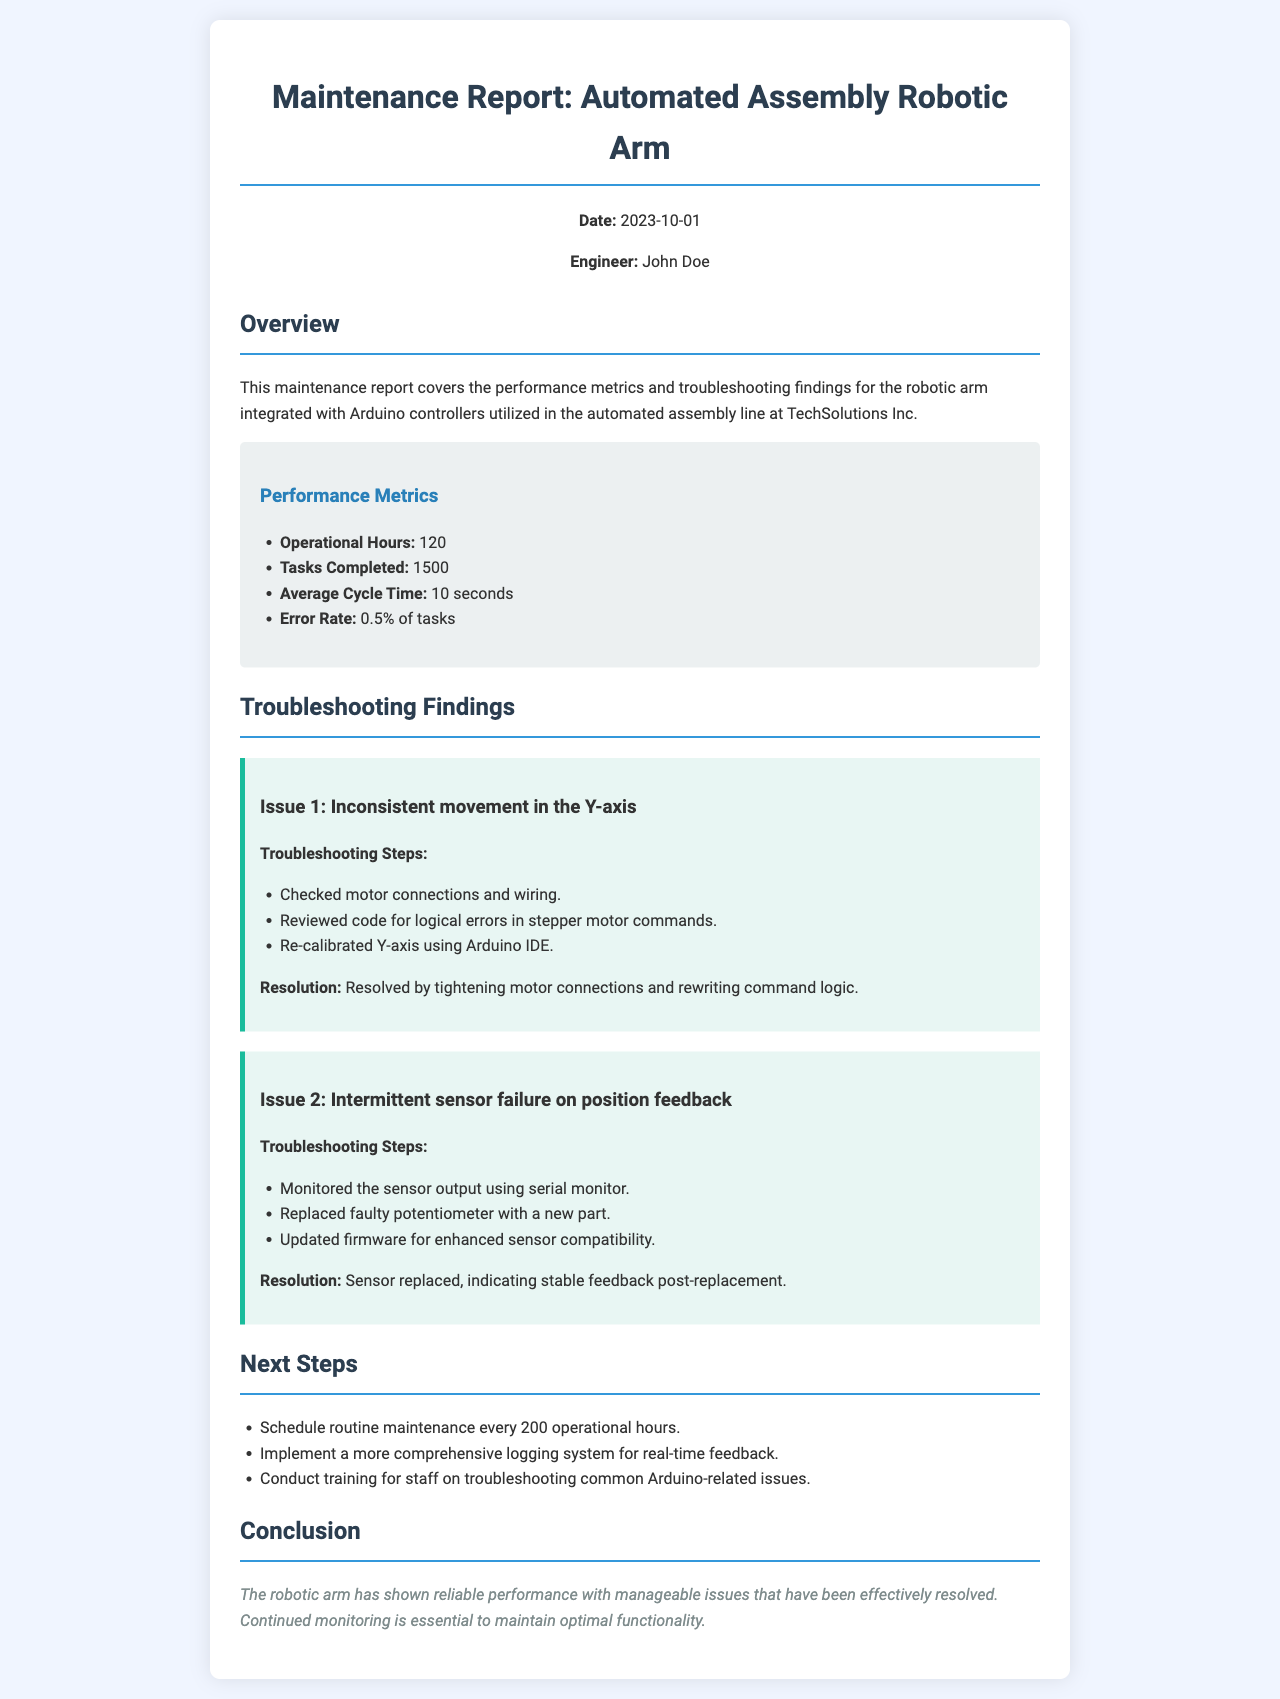What is the date of the report? The date of the report is explicitly mentioned in the document.
Answer: 2023-10-01 Who is the engineer responsible for the report? The engineer's name is provided in the document as the person responsible for the report.
Answer: John Doe How many operational hours has the robotic arm completed? The document states the number of operational hours directly.
Answer: 120 What is the error rate reported for the robotic arm? The error rate is specified as a percentage of tasks in the metrics section.
Answer: 0.5% What issue involved inconsistent movement in which axis? The document specifically identifies the Y-axis for the issue mentioned.
Answer: Y-axis What was replaced due to intermittent sensor failure? The specific component that was replaced is mentioned in the troubleshooting section.
Answer: potentiometer How many tasks were completed by the robotic arm? The total tasks completed is mentioned in the performance metrics.
Answer: 1500 What is the suggested routine maintenance schedule? The suggested routine maintenance schedule is detailed in the next steps section.
Answer: every 200 operational hours What indicates stable feedback post-replacement of the sensor? The document mentions what was observed after replacing the sensor in the resolution section.
Answer: Sensor replaced 